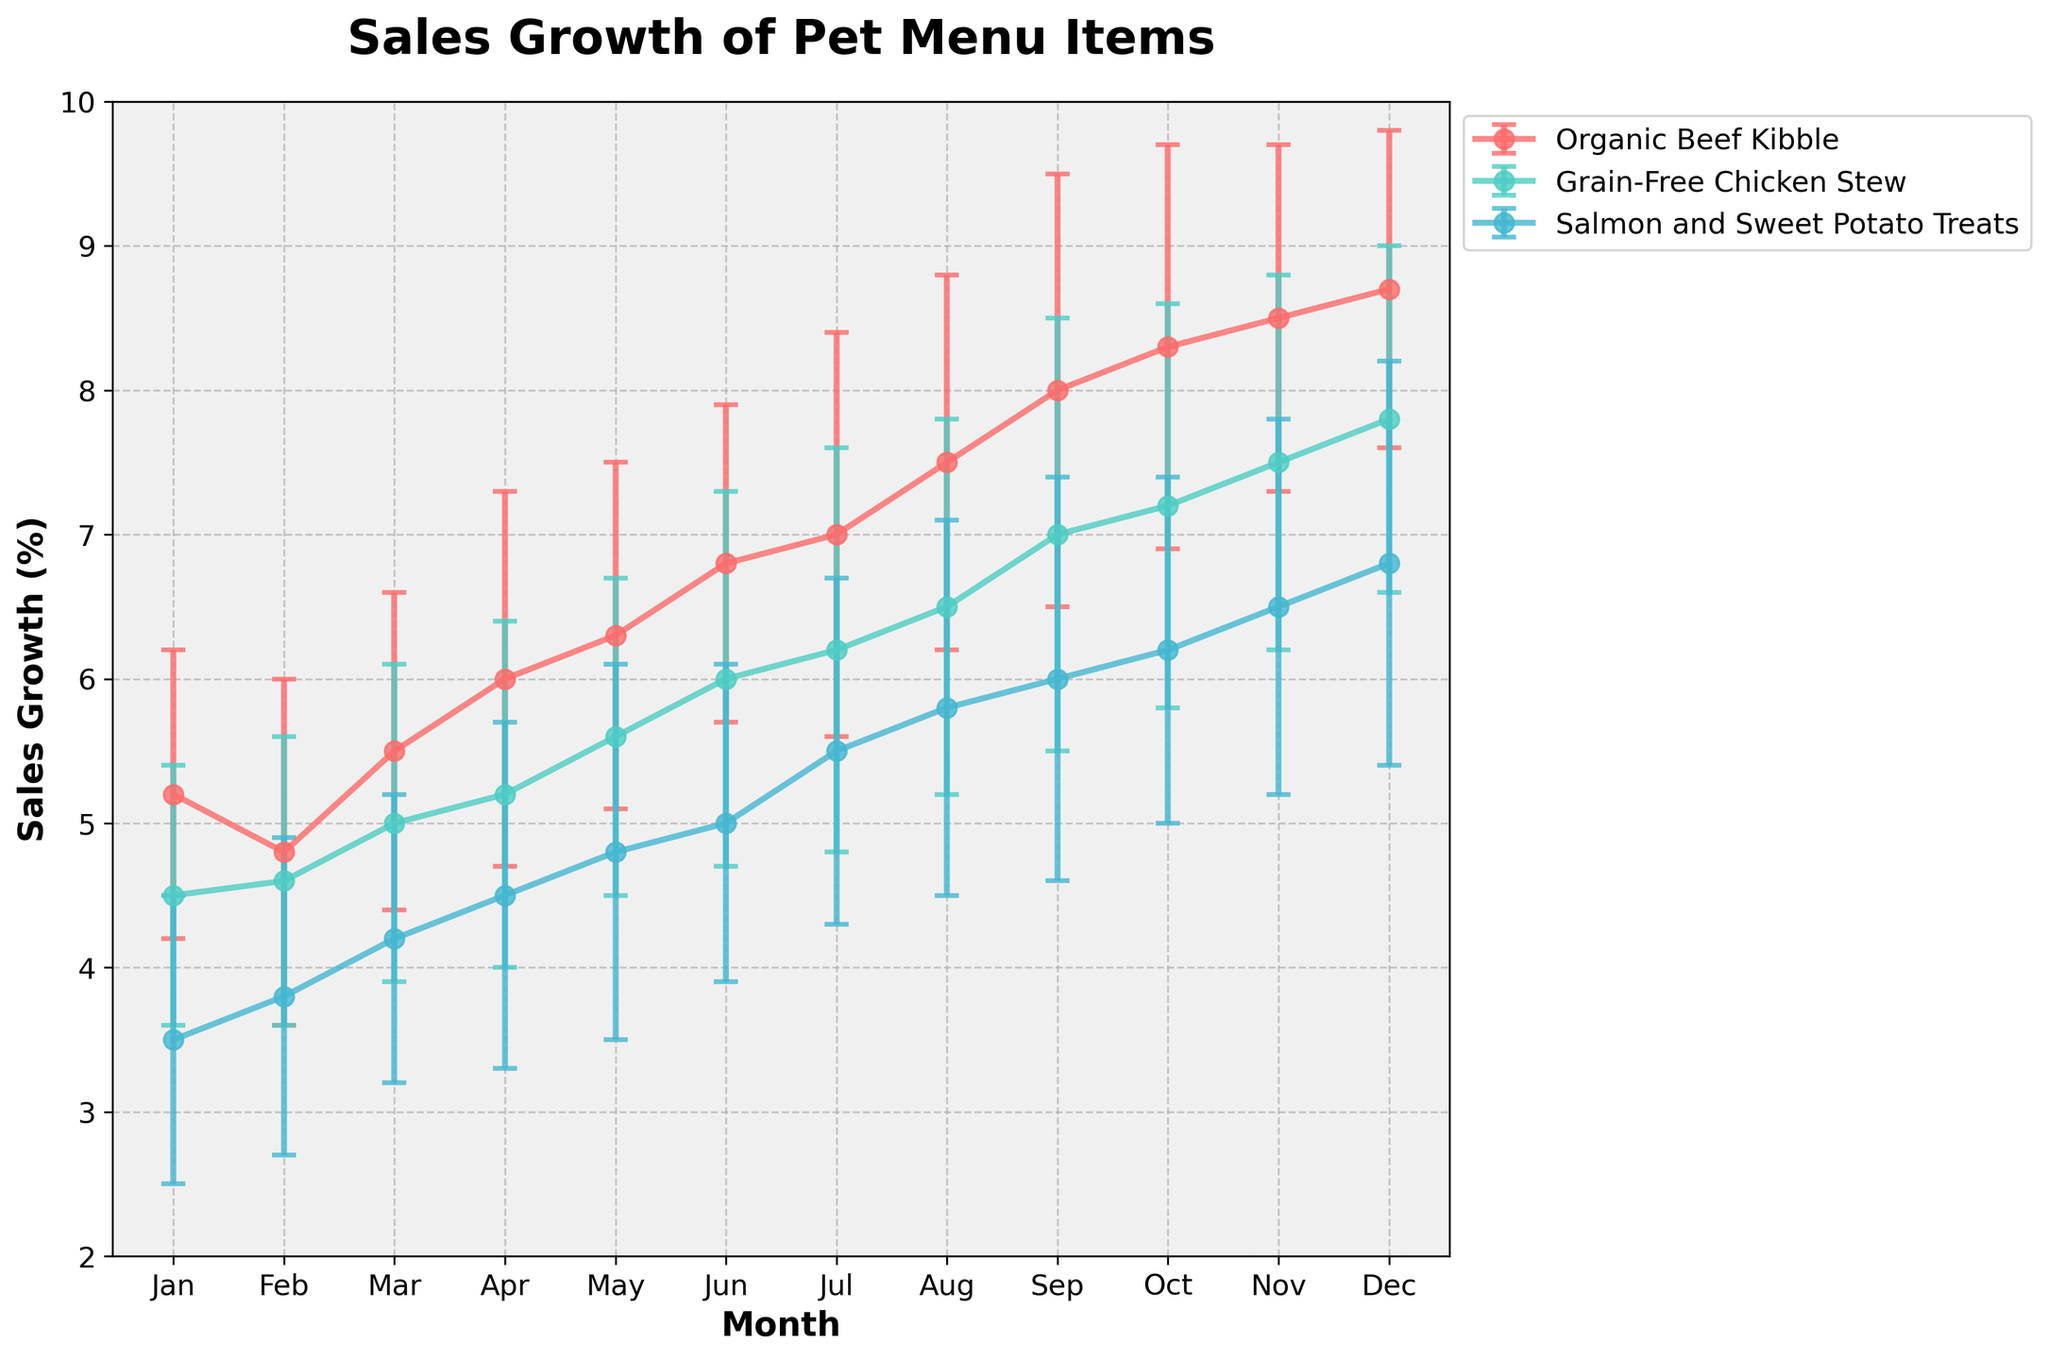Which pet menu item shows the highest sales growth in December? To find this, observe the last data point for each item in December. Identify which line reaches the highest value in December.
Answer: Organic Beef Kibble During which months does Grain-Free Chicken Stew have a higher sales growth compared to Organic Beef Kibble? Compare the sales growth values month-by-month for both items. Look for months where the line for Grain-Free Chicken Stew is above the line for Organic Beef Kibble.
Answer: None What is the range of sales growth values for Salmon and Sweet Potato Treats throughout the year? Identify the maximum and minimum sales growth percentages for Salmon and Sweet Potato Treats across all months. The range is the difference between these two values.
Answer: 3.3 Which month had the highest combined sales growth across all items? Sum the sales growth percentages for all items for each month and identify the month with the highest sum.
Answer: December What is the average sales growth for Organic Beef Kibble from January to June? Sum the sales growth percentages for Organic Beef Kibble from January to June and divide by 6.
Answer: 5.93 In which month did the sales growth of Grain-Free Chicken Stew surpass 5% for the first time? Identify the month where the sales growth of Grain-Free Chicken Stew first exceeds 5%.
Answer: March Compare the variability of sales growth for Organic Beef Kibble and Grain-Free Chicken Stew in October. Look at the error bars for both items in October. The heights of the error bars represent the variability.
Answer: Equal How does the sales growth trend of Organic Beef Kibble compare to that of Salmon and Sweet Potato Treats throughout the year? Analyze the overall direction and slope of the lines representing both items from January to December.
Answer: Steeper trend for Organic Beef Kibble Which pet menu item shows the least variability in sales growth throughout the year? Consider the length of the error bars for each item across all months. The item with the shortest error bars on average has the least variability.
Answer: Salmon and Sweet Potato Treats What is the total sales growth for Grain-Free Chicken Stew in the second half of the year (July to December)? Sum the sales growth percentages for Grain-Free Chicken Stew from July to December.
Answer: 40.2 